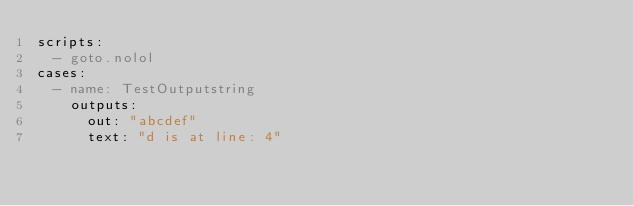Convert code to text. <code><loc_0><loc_0><loc_500><loc_500><_YAML_>scripts: 
  - goto.nolol
cases:
  - name: TestOutputstring
    outputs:
      out: "abcdef"
      text: "d is at line: 4"
</code> 